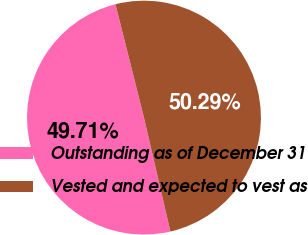Convert chart to OTSL. <chart><loc_0><loc_0><loc_500><loc_500><pie_chart><fcel>Outstanding as of December 31<fcel>Vested and expected to vest as<nl><fcel>49.71%<fcel>50.29%<nl></chart> 